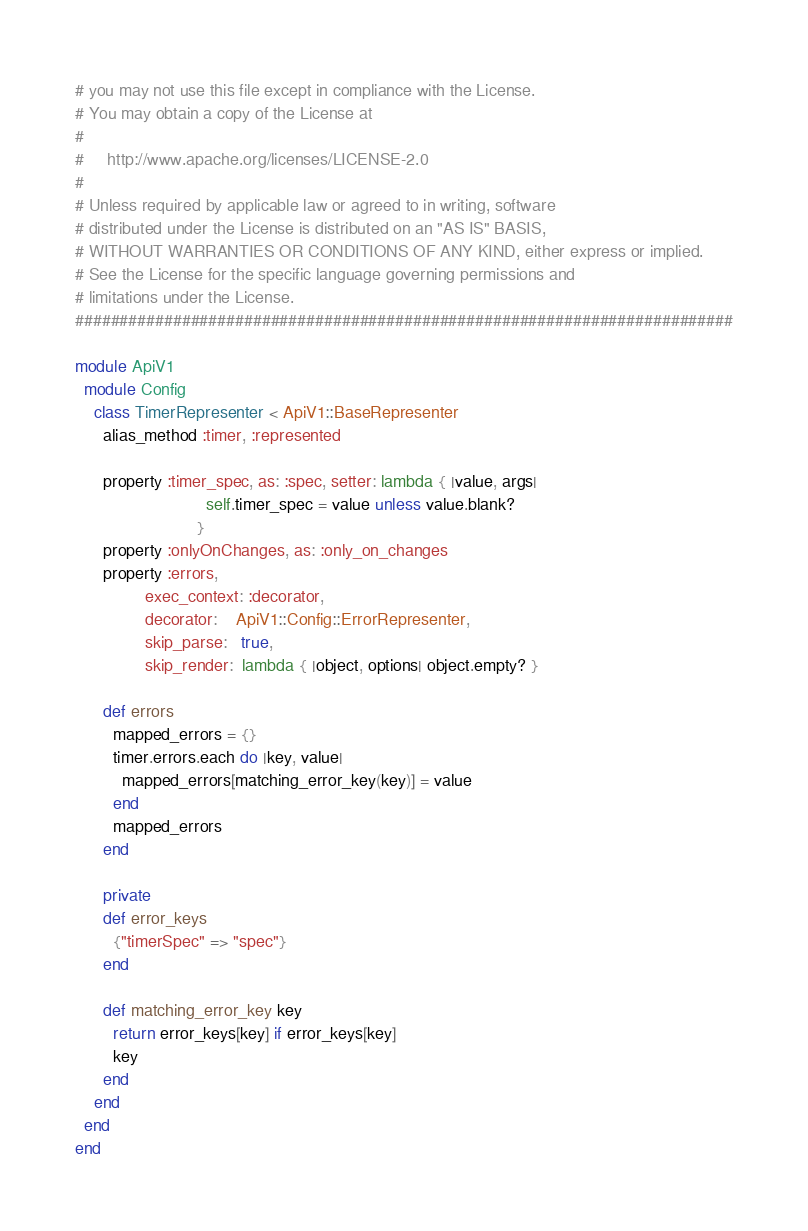Convert code to text. <code><loc_0><loc_0><loc_500><loc_500><_Ruby_># you may not use this file except in compliance with the License.
# You may obtain a copy of the License at
#
#     http://www.apache.org/licenses/LICENSE-2.0
#
# Unless required by applicable law or agreed to in writing, software
# distributed under the License is distributed on an "AS IS" BASIS,
# WITHOUT WARRANTIES OR CONDITIONS OF ANY KIND, either express or implied.
# See the License for the specific language governing permissions and
# limitations under the License.
##########################################################################

module ApiV1
  module Config
    class TimerRepresenter < ApiV1::BaseRepresenter
      alias_method :timer, :represented

      property :timer_spec, as: :spec, setter: lambda { |value, args|
                            self.timer_spec = value unless value.blank?
                          }
      property :onlyOnChanges, as: :only_on_changes
      property :errors,
               exec_context: :decorator,
               decorator:    ApiV1::Config::ErrorRepresenter,
               skip_parse:   true,
               skip_render:  lambda { |object, options| object.empty? }

      def errors
        mapped_errors = {}
        timer.errors.each do |key, value|
          mapped_errors[matching_error_key(key)] = value
        end
        mapped_errors
      end

      private
      def error_keys
        {"timerSpec" => "spec"}
      end

      def matching_error_key key
        return error_keys[key] if error_keys[key]
        key
      end
    end
  end
end
</code> 